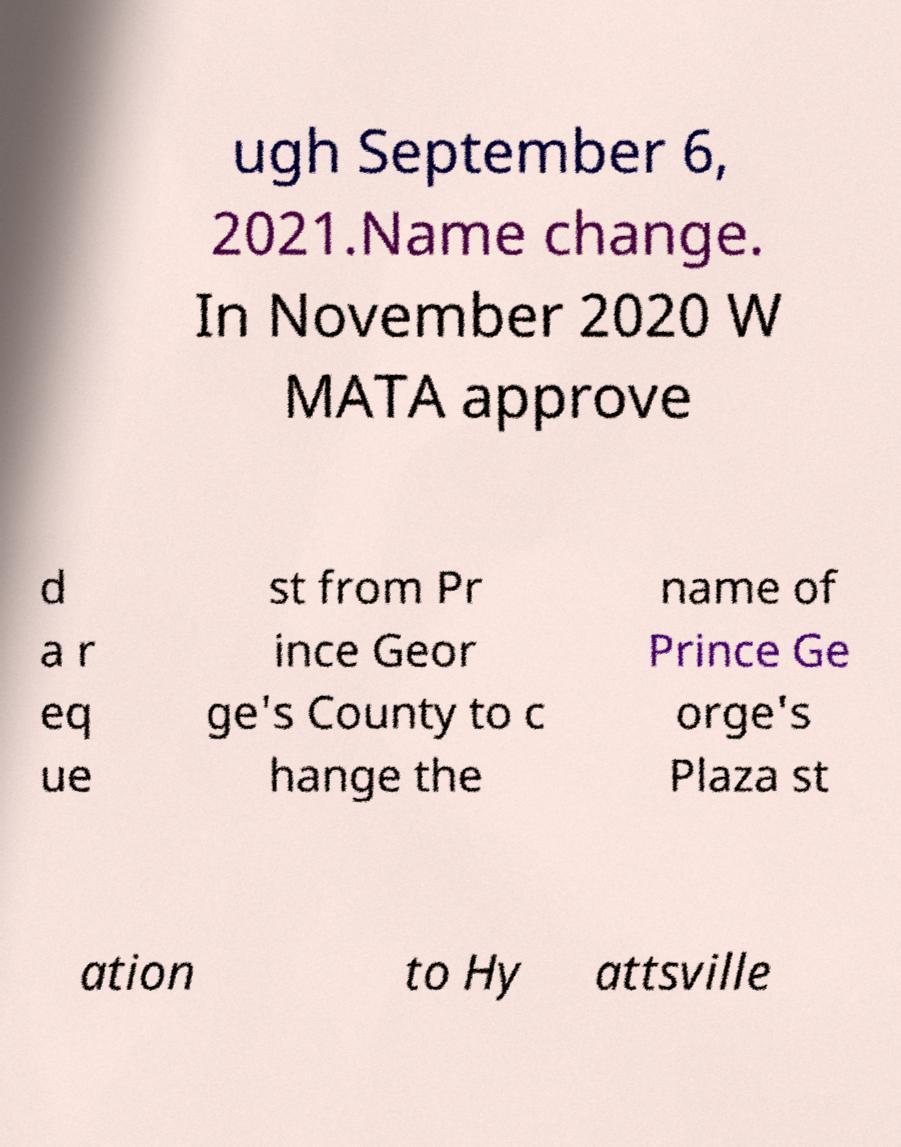Could you extract and type out the text from this image? ugh September 6, 2021.Name change. In November 2020 W MATA approve d a r eq ue st from Pr ince Geor ge's County to c hange the name of Prince Ge orge's Plaza st ation to Hy attsville 